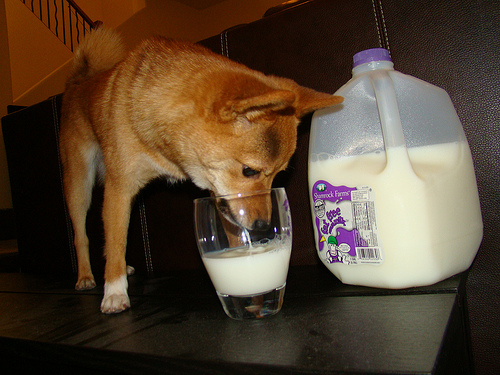<image>
Is the dog in the milk? No. The dog is not contained within the milk. These objects have a different spatial relationship. Is the milk in the cup? No. The milk is not contained within the cup. These objects have a different spatial relationship. 